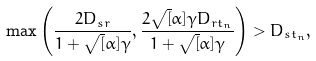Convert formula to latex. <formula><loc_0><loc_0><loc_500><loc_500>\max \left ( \frac { 2 D _ { s r } } { 1 + \sqrt { [ } \alpha ] { \gamma } } , \frac { 2 \sqrt { [ } \alpha ] { \gamma } D _ { r t _ { n } } } { 1 + \sqrt { [ } \alpha ] { \gamma } } \right ) > D _ { s t _ { n } } ,</formula> 